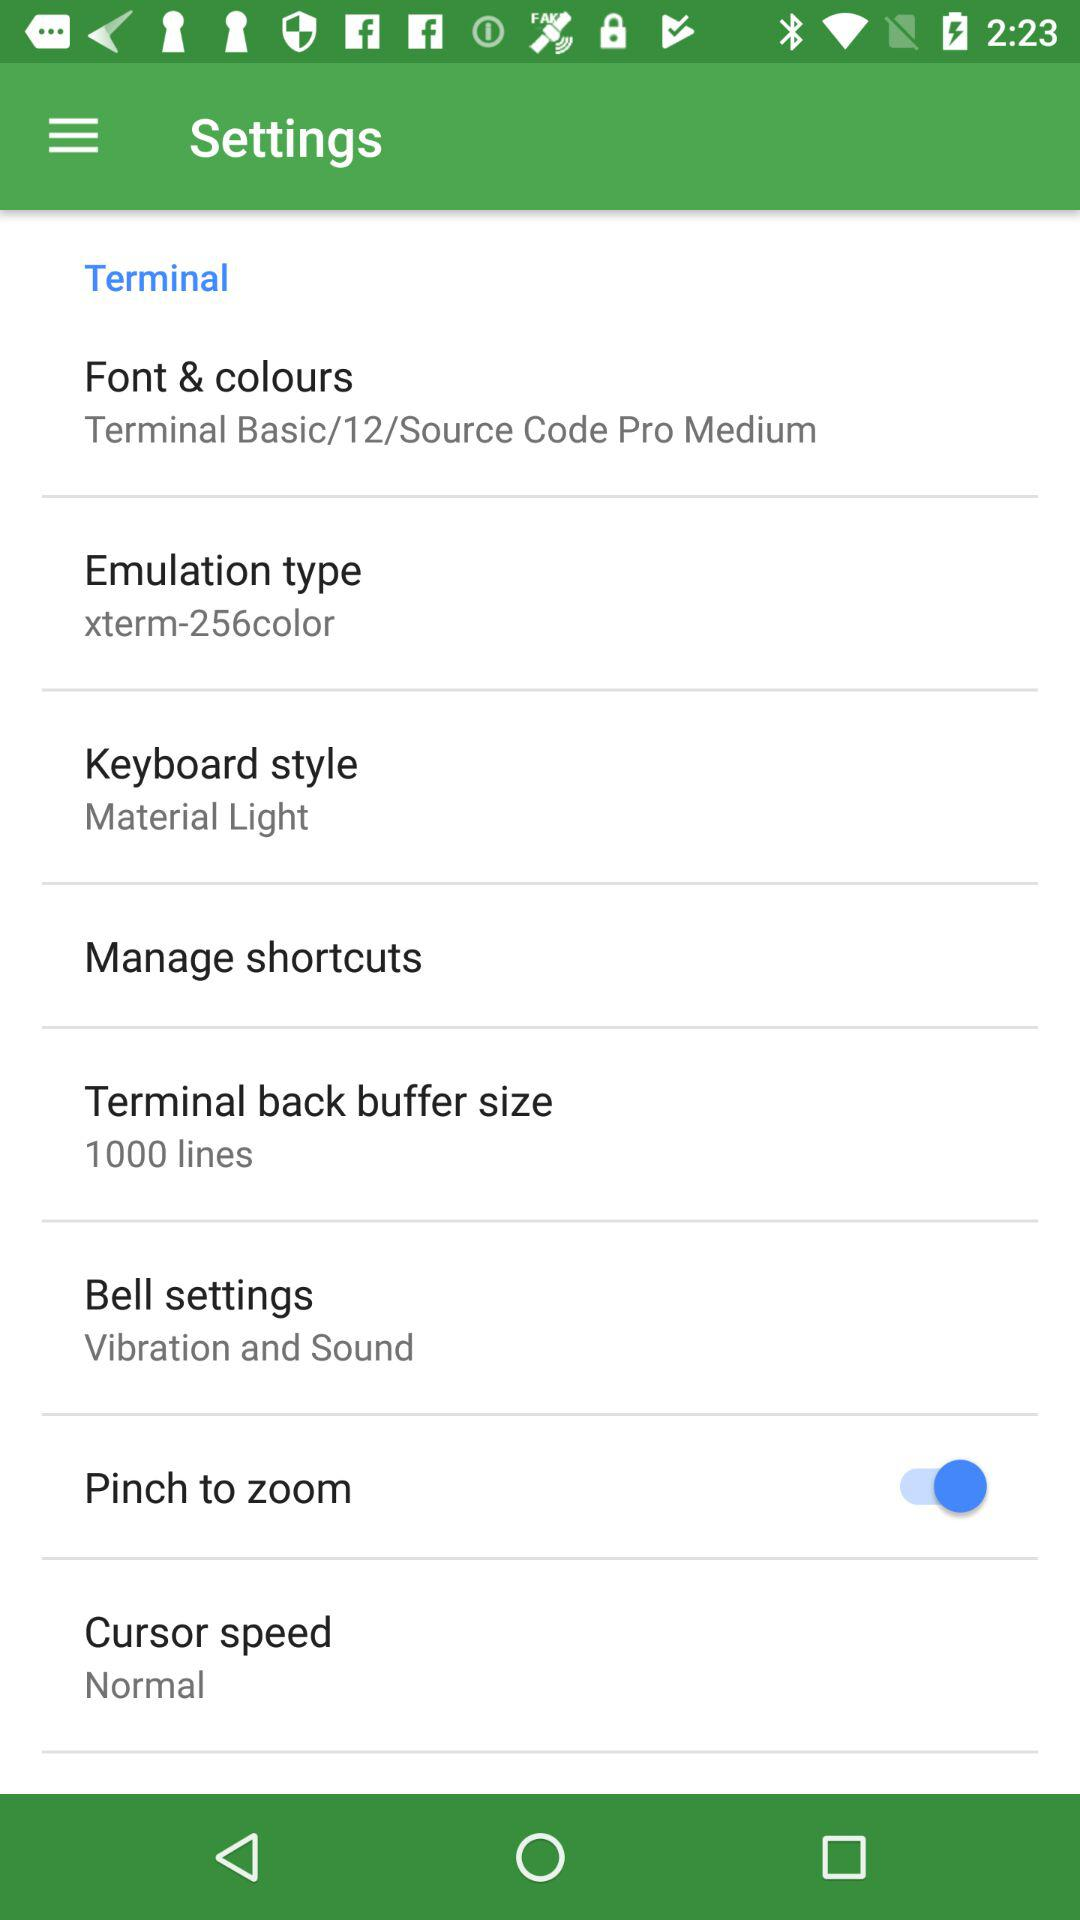What is the status of "Pinch to zoom"? The status of "Pinch to zoom" is "on". 